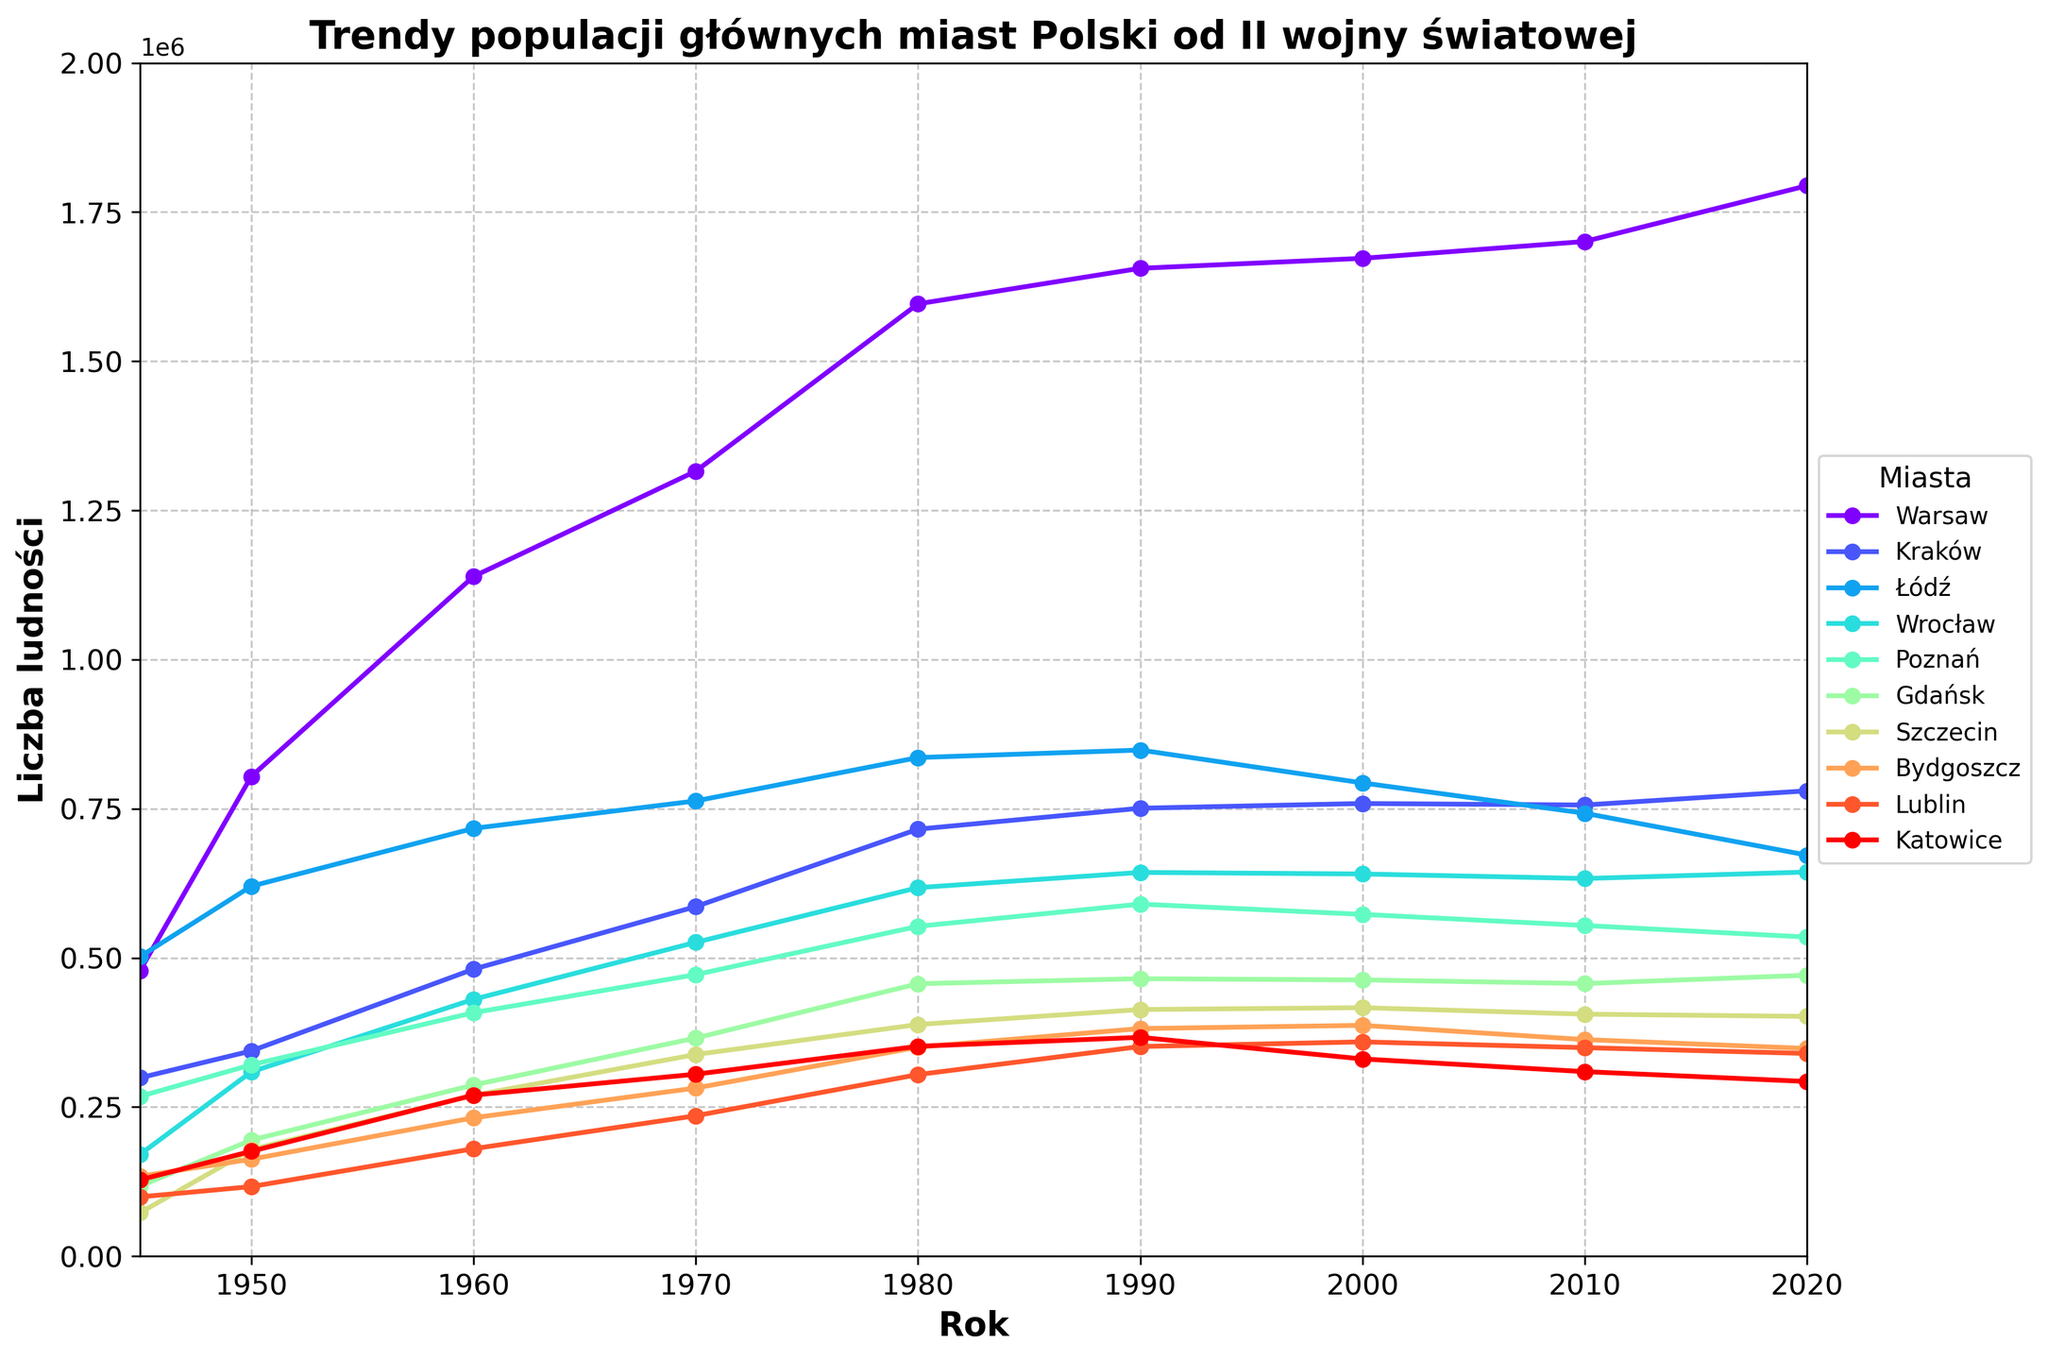What's the population difference between Warsaw and Kraków in 2020? To find the difference, look at the 2020 population values for Warsaw and Kraków. Subtract the population of Kraków from Warsaw: 1794166 - 779966 = 1014200
Answer: 1014200 Which city had the largest population in 1945? Check the 1945 population values for all cities. Warsaw had the highest population of 478755 in 1945, making it the largest
Answer: Warsaw Has the population of Łódź increased or decreased from 1990 to 2020? Compare the population of Łódź in 1990 and 2020. The 1990 population was 848300 and the 2020 population was 672185, showing a decrease
Answer: Decreased What is the average population of Poznań from 1945 to 2020? Sum the population values for Poznań over the years and then divide by the number of data points: (267900+320700+408100+471900+552900+590101+572900+554221+534813)/9 ≈ 467504.89
Answer: 467504.89 Which city had the most consistent population growth from 1945 to 2020? Analyze the population trends for all cities. Warsaw shows a continuous and consistent growth pattern with no significant dips
Answer: Warsaw Between which consecutive decades did Wrocław experience the highest population growth? Calculate the population difference for each consecutive decade for Wrocław. The highest growth was between 1945 and 1950: 308900 - 170700 = 138200
Answer: 1945-1950 What is the combined population of Szczecin and Bydgoszcz in 2020? Add the 2020 populations of Szczecin and Bydgoszcz: 401907 + 348190 = 750097
Answer: 750097 How did the population of Gdańsk change between 1945 and 1980? Look at the 1945 and 1980 population values for Gdańsk. The 1945 population was 117500 and the 1980 population was 456700. The increase is 456700 - 117500 = 339200
Answer: Increased by 339200 By how much did Katowice's population decline from its peak in 1980? The peak population in 1980 was 351800, and the population in 2020 was 292774. The decline is 351800 - 292774 = 59026
Answer: 59026 